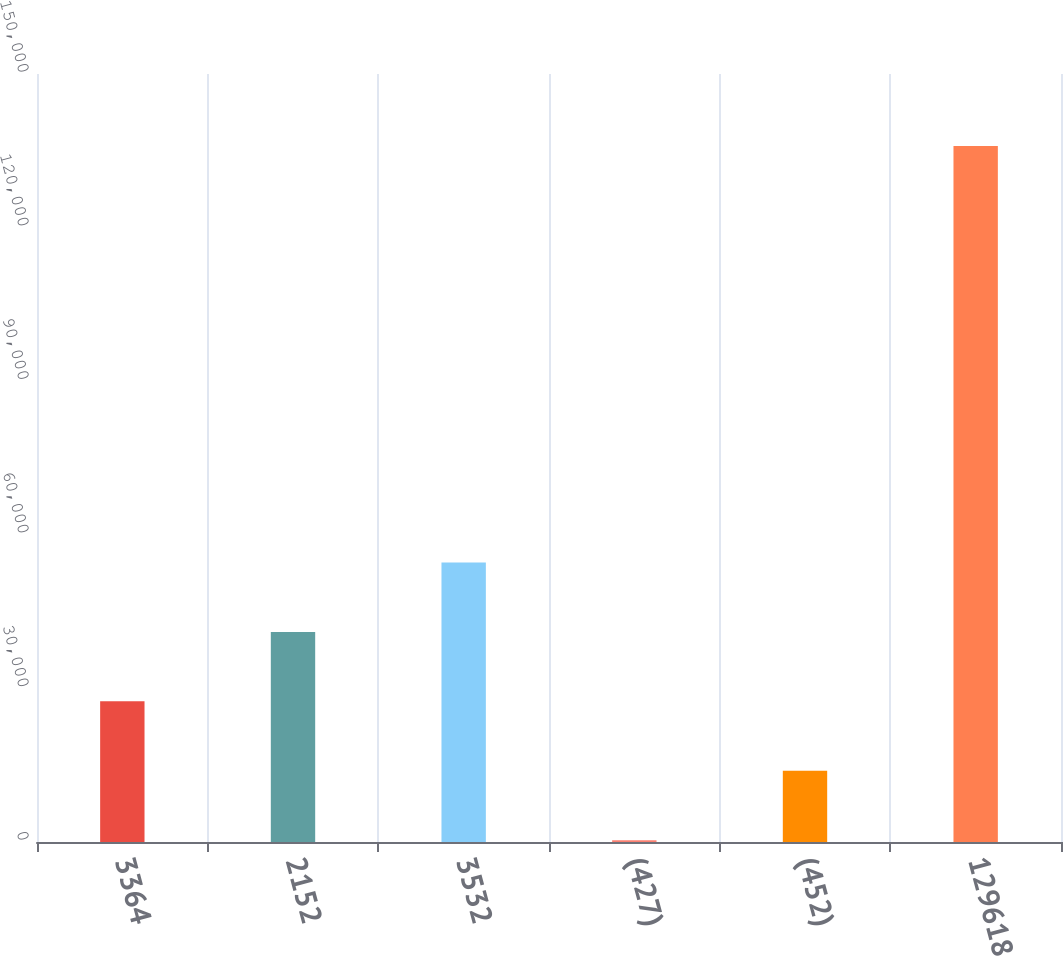Convert chart. <chart><loc_0><loc_0><loc_500><loc_500><bar_chart><fcel>3364<fcel>2152<fcel>3532<fcel>(427)<fcel>(452)<fcel>129618<nl><fcel>27467.8<fcel>41028.7<fcel>54589.6<fcel>346<fcel>13906.9<fcel>135955<nl></chart> 